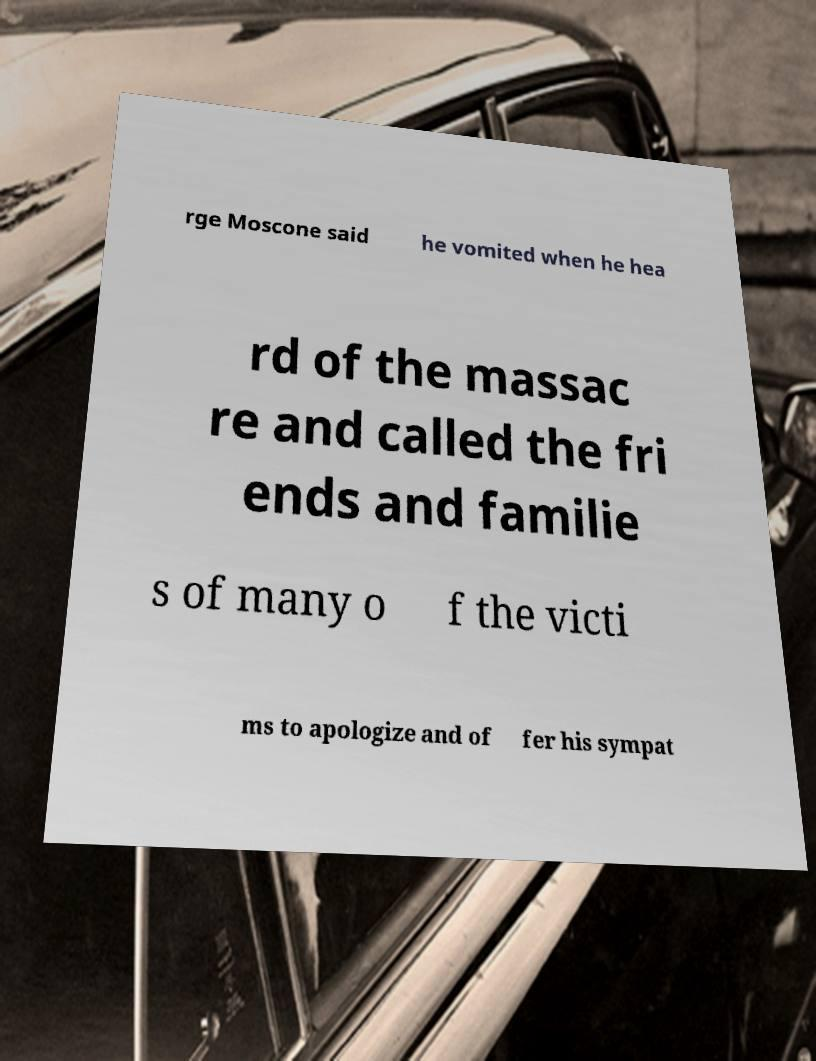There's text embedded in this image that I need extracted. Can you transcribe it verbatim? rge Moscone said he vomited when he hea rd of the massac re and called the fri ends and familie s of many o f the victi ms to apologize and of fer his sympat 